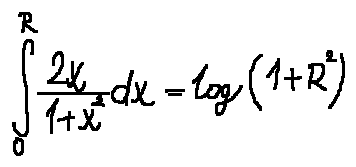Convert formula to latex. <formula><loc_0><loc_0><loc_500><loc_500>\int \lim i t s _ { 0 } ^ { R } \frac { 2 x } { 1 + x ^ { 2 } } d x = \log ( 1 + R ^ { 2 } )</formula> 